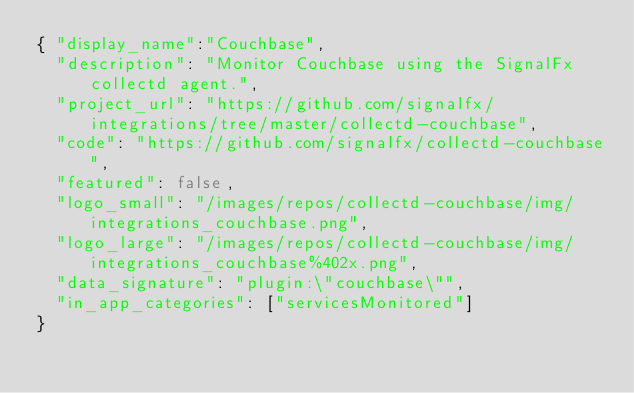<code> <loc_0><loc_0><loc_500><loc_500><_YAML_>{ "display_name":"Couchbase",
  "description": "Monitor Couchbase using the SignalFx collectd agent.",
  "project_url": "https://github.com/signalfx/integrations/tree/master/collectd-couchbase",
  "code": "https://github.com/signalfx/collectd-couchbase",
  "featured": false,
  "logo_small": "/images/repos/collectd-couchbase/img/integrations_couchbase.png",
  "logo_large": "/images/repos/collectd-couchbase/img/integrations_couchbase%402x.png",
  "data_signature": "plugin:\"couchbase\"",
  "in_app_categories": ["servicesMonitored"]
}
</code> 